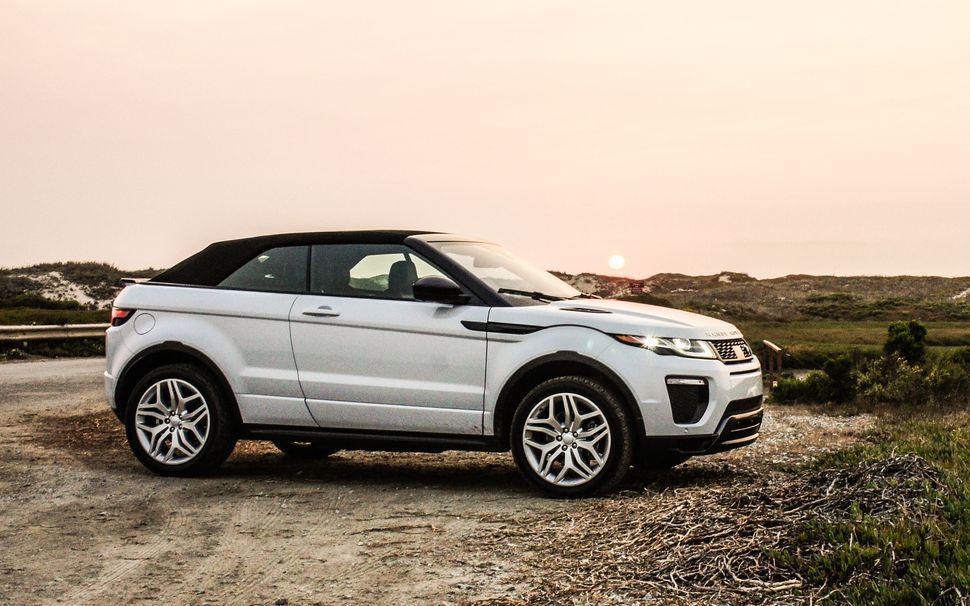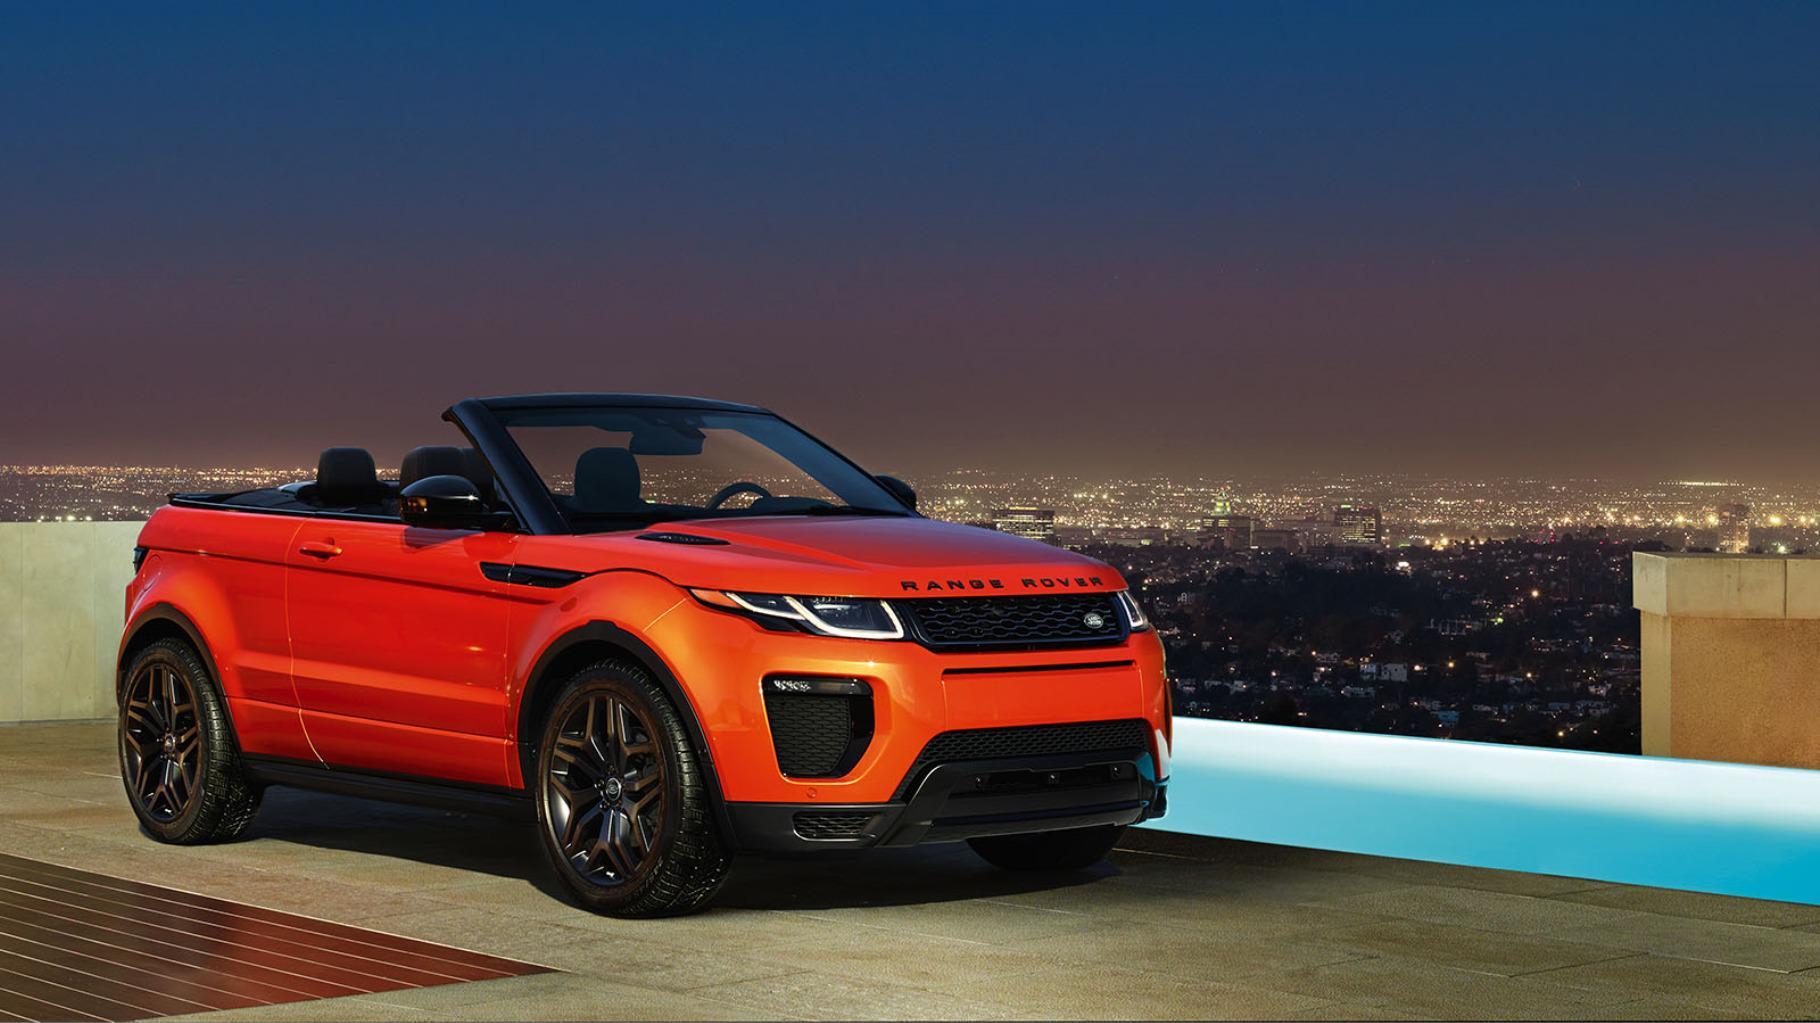The first image is the image on the left, the second image is the image on the right. Examine the images to the left and right. Is the description "a convertible is in a parking space overlooking the beach" accurate? Answer yes or no. No. The first image is the image on the left, the second image is the image on the right. For the images displayed, is the sentence "One of the images shows an orange vehicle." factually correct? Answer yes or no. Yes. 